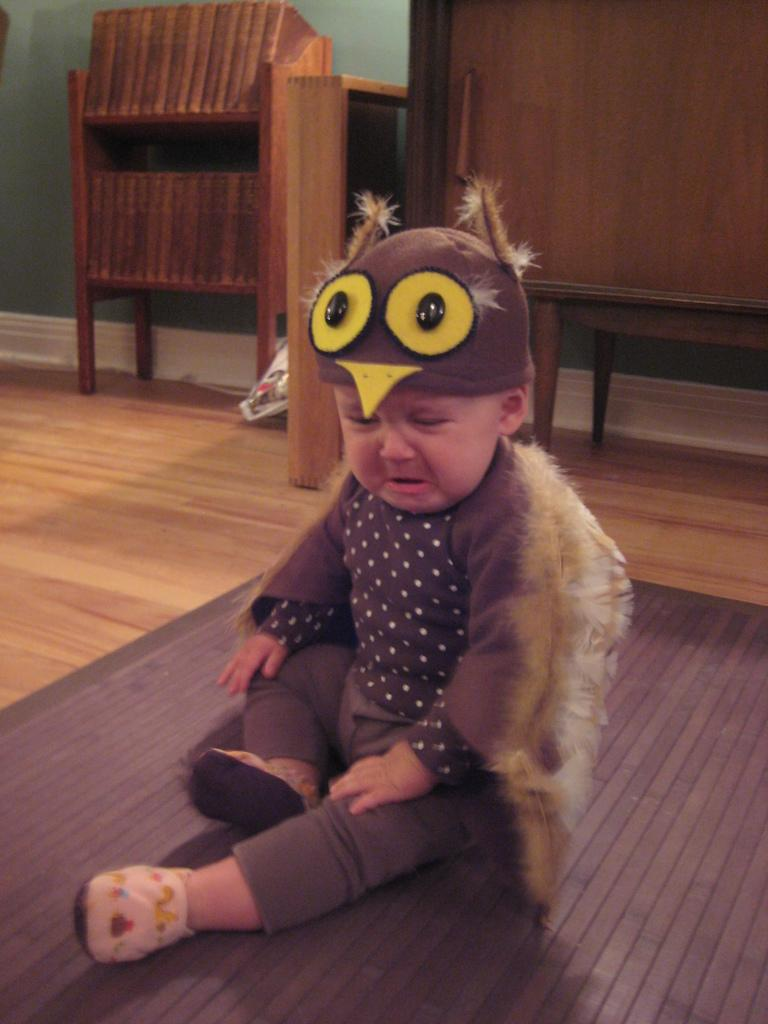What is the main subject of the image? The main subject of the image is a baby sitting. What is the baby wearing? The baby is wearing clothes, shoes, and a cap. What is the baby doing in the image? The baby is crying. What type of flooring is visible in the image? There is a carpet and a wooden floor in the image. What type of furniture is present in the image? There are wooden cupboards in the image. Is there a chair next to the baby in the image? There is no chair visible in the image. What type of plant is present in the image? There is no plant present in the image. 